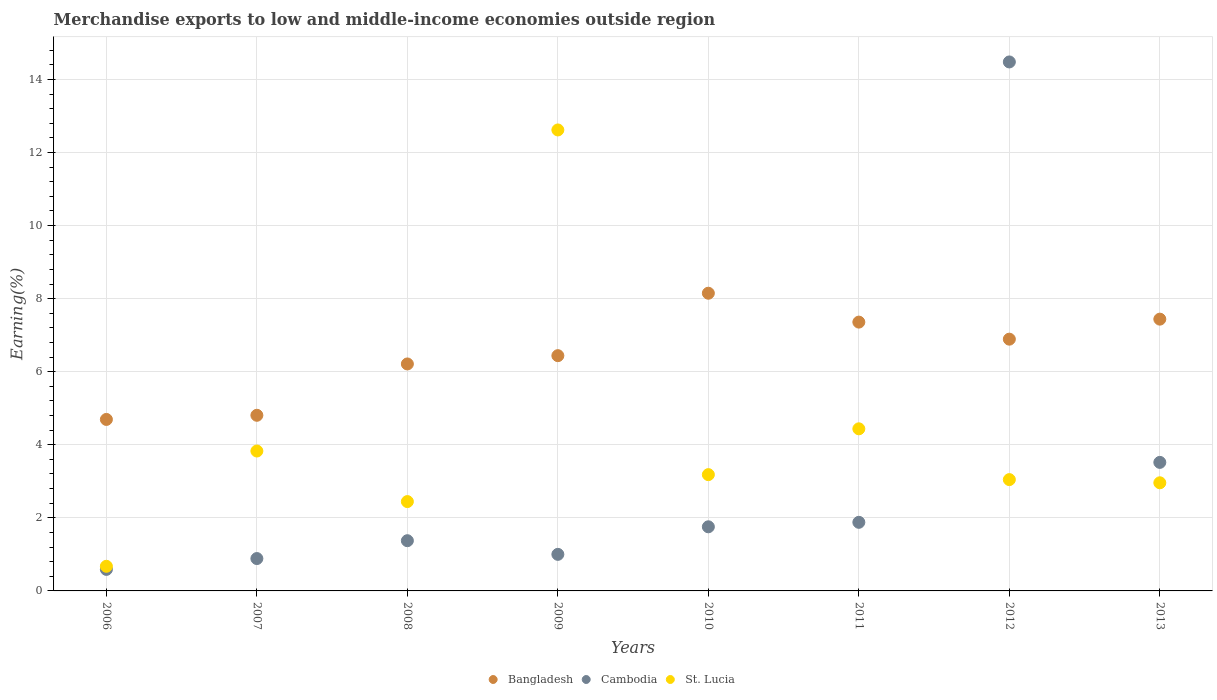What is the percentage of amount earned from merchandise exports in Cambodia in 2012?
Ensure brevity in your answer.  14.48. Across all years, what is the maximum percentage of amount earned from merchandise exports in St. Lucia?
Your answer should be very brief. 12.62. Across all years, what is the minimum percentage of amount earned from merchandise exports in Bangladesh?
Ensure brevity in your answer.  4.69. In which year was the percentage of amount earned from merchandise exports in St. Lucia maximum?
Provide a succinct answer. 2009. What is the total percentage of amount earned from merchandise exports in Cambodia in the graph?
Offer a terse response. 25.48. What is the difference between the percentage of amount earned from merchandise exports in Cambodia in 2007 and that in 2010?
Offer a terse response. -0.87. What is the difference between the percentage of amount earned from merchandise exports in Bangladesh in 2008 and the percentage of amount earned from merchandise exports in Cambodia in 2007?
Keep it short and to the point. 5.33. What is the average percentage of amount earned from merchandise exports in Bangladesh per year?
Offer a terse response. 6.5. In the year 2008, what is the difference between the percentage of amount earned from merchandise exports in Cambodia and percentage of amount earned from merchandise exports in St. Lucia?
Keep it short and to the point. -1.07. What is the ratio of the percentage of amount earned from merchandise exports in St. Lucia in 2007 to that in 2010?
Offer a very short reply. 1.2. Is the difference between the percentage of amount earned from merchandise exports in Cambodia in 2007 and 2011 greater than the difference between the percentage of amount earned from merchandise exports in St. Lucia in 2007 and 2011?
Make the answer very short. No. What is the difference between the highest and the second highest percentage of amount earned from merchandise exports in Bangladesh?
Offer a very short reply. 0.71. What is the difference between the highest and the lowest percentage of amount earned from merchandise exports in Bangladesh?
Offer a terse response. 3.45. Is the sum of the percentage of amount earned from merchandise exports in Bangladesh in 2008 and 2010 greater than the maximum percentage of amount earned from merchandise exports in St. Lucia across all years?
Offer a very short reply. Yes. Is it the case that in every year, the sum of the percentage of amount earned from merchandise exports in St. Lucia and percentage of amount earned from merchandise exports in Cambodia  is greater than the percentage of amount earned from merchandise exports in Bangladesh?
Your answer should be compact. No. Does the percentage of amount earned from merchandise exports in Cambodia monotonically increase over the years?
Your answer should be compact. No. How many years are there in the graph?
Your response must be concise. 8. What is the difference between two consecutive major ticks on the Y-axis?
Your response must be concise. 2. Does the graph contain any zero values?
Provide a short and direct response. No. Where does the legend appear in the graph?
Keep it short and to the point. Bottom center. How many legend labels are there?
Provide a succinct answer. 3. What is the title of the graph?
Your response must be concise. Merchandise exports to low and middle-income economies outside region. What is the label or title of the X-axis?
Your response must be concise. Years. What is the label or title of the Y-axis?
Your answer should be compact. Earning(%). What is the Earning(%) of Bangladesh in 2006?
Keep it short and to the point. 4.69. What is the Earning(%) in Cambodia in 2006?
Ensure brevity in your answer.  0.59. What is the Earning(%) of St. Lucia in 2006?
Give a very brief answer. 0.67. What is the Earning(%) in Bangladesh in 2007?
Keep it short and to the point. 4.81. What is the Earning(%) in Cambodia in 2007?
Give a very brief answer. 0.89. What is the Earning(%) of St. Lucia in 2007?
Offer a terse response. 3.83. What is the Earning(%) in Bangladesh in 2008?
Keep it short and to the point. 6.21. What is the Earning(%) in Cambodia in 2008?
Keep it short and to the point. 1.37. What is the Earning(%) of St. Lucia in 2008?
Provide a succinct answer. 2.45. What is the Earning(%) in Bangladesh in 2009?
Ensure brevity in your answer.  6.44. What is the Earning(%) of Cambodia in 2009?
Make the answer very short. 1. What is the Earning(%) in St. Lucia in 2009?
Give a very brief answer. 12.62. What is the Earning(%) of Bangladesh in 2010?
Your response must be concise. 8.15. What is the Earning(%) of Cambodia in 2010?
Offer a very short reply. 1.75. What is the Earning(%) in St. Lucia in 2010?
Keep it short and to the point. 3.18. What is the Earning(%) of Bangladesh in 2011?
Your answer should be compact. 7.36. What is the Earning(%) in Cambodia in 2011?
Keep it short and to the point. 1.88. What is the Earning(%) in St. Lucia in 2011?
Your response must be concise. 4.44. What is the Earning(%) of Bangladesh in 2012?
Your response must be concise. 6.89. What is the Earning(%) in Cambodia in 2012?
Give a very brief answer. 14.48. What is the Earning(%) in St. Lucia in 2012?
Your answer should be compact. 3.05. What is the Earning(%) in Bangladesh in 2013?
Provide a short and direct response. 7.44. What is the Earning(%) in Cambodia in 2013?
Your answer should be compact. 3.52. What is the Earning(%) of St. Lucia in 2013?
Provide a succinct answer. 2.96. Across all years, what is the maximum Earning(%) of Bangladesh?
Provide a succinct answer. 8.15. Across all years, what is the maximum Earning(%) of Cambodia?
Keep it short and to the point. 14.48. Across all years, what is the maximum Earning(%) of St. Lucia?
Your answer should be very brief. 12.62. Across all years, what is the minimum Earning(%) of Bangladesh?
Make the answer very short. 4.69. Across all years, what is the minimum Earning(%) in Cambodia?
Your answer should be compact. 0.59. Across all years, what is the minimum Earning(%) of St. Lucia?
Your answer should be very brief. 0.67. What is the total Earning(%) of Bangladesh in the graph?
Your answer should be very brief. 51.98. What is the total Earning(%) of Cambodia in the graph?
Your answer should be compact. 25.48. What is the total Earning(%) of St. Lucia in the graph?
Provide a short and direct response. 33.19. What is the difference between the Earning(%) of Bangladesh in 2006 and that in 2007?
Offer a very short reply. -0.11. What is the difference between the Earning(%) in Cambodia in 2006 and that in 2007?
Your answer should be very brief. -0.3. What is the difference between the Earning(%) in St. Lucia in 2006 and that in 2007?
Your answer should be very brief. -3.15. What is the difference between the Earning(%) of Bangladesh in 2006 and that in 2008?
Your answer should be compact. -1.52. What is the difference between the Earning(%) in Cambodia in 2006 and that in 2008?
Provide a succinct answer. -0.79. What is the difference between the Earning(%) in St. Lucia in 2006 and that in 2008?
Your answer should be very brief. -1.77. What is the difference between the Earning(%) of Bangladesh in 2006 and that in 2009?
Your answer should be compact. -1.75. What is the difference between the Earning(%) in Cambodia in 2006 and that in 2009?
Offer a very short reply. -0.41. What is the difference between the Earning(%) of St. Lucia in 2006 and that in 2009?
Offer a terse response. -11.94. What is the difference between the Earning(%) in Bangladesh in 2006 and that in 2010?
Ensure brevity in your answer.  -3.45. What is the difference between the Earning(%) of Cambodia in 2006 and that in 2010?
Offer a very short reply. -1.17. What is the difference between the Earning(%) of St. Lucia in 2006 and that in 2010?
Provide a short and direct response. -2.51. What is the difference between the Earning(%) of Bangladesh in 2006 and that in 2011?
Provide a short and direct response. -2.66. What is the difference between the Earning(%) in Cambodia in 2006 and that in 2011?
Provide a succinct answer. -1.29. What is the difference between the Earning(%) in St. Lucia in 2006 and that in 2011?
Your response must be concise. -3.76. What is the difference between the Earning(%) in Bangladesh in 2006 and that in 2012?
Your response must be concise. -2.2. What is the difference between the Earning(%) in Cambodia in 2006 and that in 2012?
Make the answer very short. -13.89. What is the difference between the Earning(%) of St. Lucia in 2006 and that in 2012?
Ensure brevity in your answer.  -2.37. What is the difference between the Earning(%) of Bangladesh in 2006 and that in 2013?
Keep it short and to the point. -2.74. What is the difference between the Earning(%) of Cambodia in 2006 and that in 2013?
Ensure brevity in your answer.  -2.93. What is the difference between the Earning(%) of St. Lucia in 2006 and that in 2013?
Give a very brief answer. -2.29. What is the difference between the Earning(%) in Bangladesh in 2007 and that in 2008?
Offer a terse response. -1.41. What is the difference between the Earning(%) of Cambodia in 2007 and that in 2008?
Offer a terse response. -0.49. What is the difference between the Earning(%) of St. Lucia in 2007 and that in 2008?
Provide a short and direct response. 1.38. What is the difference between the Earning(%) of Bangladesh in 2007 and that in 2009?
Provide a short and direct response. -1.63. What is the difference between the Earning(%) in Cambodia in 2007 and that in 2009?
Ensure brevity in your answer.  -0.11. What is the difference between the Earning(%) of St. Lucia in 2007 and that in 2009?
Your response must be concise. -8.79. What is the difference between the Earning(%) in Bangladesh in 2007 and that in 2010?
Provide a succinct answer. -3.34. What is the difference between the Earning(%) in Cambodia in 2007 and that in 2010?
Your response must be concise. -0.87. What is the difference between the Earning(%) in St. Lucia in 2007 and that in 2010?
Give a very brief answer. 0.65. What is the difference between the Earning(%) in Bangladesh in 2007 and that in 2011?
Provide a succinct answer. -2.55. What is the difference between the Earning(%) in Cambodia in 2007 and that in 2011?
Ensure brevity in your answer.  -0.99. What is the difference between the Earning(%) of St. Lucia in 2007 and that in 2011?
Give a very brief answer. -0.61. What is the difference between the Earning(%) of Bangladesh in 2007 and that in 2012?
Provide a succinct answer. -2.08. What is the difference between the Earning(%) of Cambodia in 2007 and that in 2012?
Your answer should be compact. -13.59. What is the difference between the Earning(%) in St. Lucia in 2007 and that in 2012?
Provide a short and direct response. 0.78. What is the difference between the Earning(%) of Bangladesh in 2007 and that in 2013?
Ensure brevity in your answer.  -2.63. What is the difference between the Earning(%) of Cambodia in 2007 and that in 2013?
Keep it short and to the point. -2.63. What is the difference between the Earning(%) of St. Lucia in 2007 and that in 2013?
Ensure brevity in your answer.  0.87. What is the difference between the Earning(%) in Bangladesh in 2008 and that in 2009?
Offer a terse response. -0.23. What is the difference between the Earning(%) in Cambodia in 2008 and that in 2009?
Ensure brevity in your answer.  0.37. What is the difference between the Earning(%) of St. Lucia in 2008 and that in 2009?
Offer a very short reply. -10.17. What is the difference between the Earning(%) of Bangladesh in 2008 and that in 2010?
Keep it short and to the point. -1.94. What is the difference between the Earning(%) in Cambodia in 2008 and that in 2010?
Your response must be concise. -0.38. What is the difference between the Earning(%) in St. Lucia in 2008 and that in 2010?
Offer a terse response. -0.74. What is the difference between the Earning(%) of Bangladesh in 2008 and that in 2011?
Offer a terse response. -1.15. What is the difference between the Earning(%) in Cambodia in 2008 and that in 2011?
Ensure brevity in your answer.  -0.5. What is the difference between the Earning(%) of St. Lucia in 2008 and that in 2011?
Ensure brevity in your answer.  -1.99. What is the difference between the Earning(%) in Bangladesh in 2008 and that in 2012?
Offer a terse response. -0.68. What is the difference between the Earning(%) of Cambodia in 2008 and that in 2012?
Provide a short and direct response. -13.1. What is the difference between the Earning(%) of St. Lucia in 2008 and that in 2012?
Provide a short and direct response. -0.6. What is the difference between the Earning(%) in Bangladesh in 2008 and that in 2013?
Make the answer very short. -1.23. What is the difference between the Earning(%) of Cambodia in 2008 and that in 2013?
Give a very brief answer. -2.14. What is the difference between the Earning(%) of St. Lucia in 2008 and that in 2013?
Give a very brief answer. -0.51. What is the difference between the Earning(%) in Bangladesh in 2009 and that in 2010?
Your answer should be very brief. -1.71. What is the difference between the Earning(%) of Cambodia in 2009 and that in 2010?
Give a very brief answer. -0.75. What is the difference between the Earning(%) in St. Lucia in 2009 and that in 2010?
Your answer should be very brief. 9.43. What is the difference between the Earning(%) in Bangladesh in 2009 and that in 2011?
Your answer should be very brief. -0.92. What is the difference between the Earning(%) in Cambodia in 2009 and that in 2011?
Your response must be concise. -0.88. What is the difference between the Earning(%) of St. Lucia in 2009 and that in 2011?
Your response must be concise. 8.18. What is the difference between the Earning(%) of Bangladesh in 2009 and that in 2012?
Keep it short and to the point. -0.45. What is the difference between the Earning(%) of Cambodia in 2009 and that in 2012?
Your response must be concise. -13.48. What is the difference between the Earning(%) in St. Lucia in 2009 and that in 2012?
Ensure brevity in your answer.  9.57. What is the difference between the Earning(%) in Bangladesh in 2009 and that in 2013?
Provide a short and direct response. -1. What is the difference between the Earning(%) of Cambodia in 2009 and that in 2013?
Offer a very short reply. -2.52. What is the difference between the Earning(%) of St. Lucia in 2009 and that in 2013?
Offer a terse response. 9.66. What is the difference between the Earning(%) in Bangladesh in 2010 and that in 2011?
Offer a very short reply. 0.79. What is the difference between the Earning(%) in Cambodia in 2010 and that in 2011?
Give a very brief answer. -0.12. What is the difference between the Earning(%) of St. Lucia in 2010 and that in 2011?
Offer a terse response. -1.25. What is the difference between the Earning(%) of Bangladesh in 2010 and that in 2012?
Make the answer very short. 1.26. What is the difference between the Earning(%) of Cambodia in 2010 and that in 2012?
Your answer should be compact. -12.72. What is the difference between the Earning(%) of St. Lucia in 2010 and that in 2012?
Offer a very short reply. 0.14. What is the difference between the Earning(%) in Bangladesh in 2010 and that in 2013?
Provide a short and direct response. 0.71. What is the difference between the Earning(%) of Cambodia in 2010 and that in 2013?
Offer a very short reply. -1.76. What is the difference between the Earning(%) of St. Lucia in 2010 and that in 2013?
Provide a succinct answer. 0.22. What is the difference between the Earning(%) in Bangladesh in 2011 and that in 2012?
Your response must be concise. 0.47. What is the difference between the Earning(%) of Cambodia in 2011 and that in 2012?
Keep it short and to the point. -12.6. What is the difference between the Earning(%) of St. Lucia in 2011 and that in 2012?
Give a very brief answer. 1.39. What is the difference between the Earning(%) of Bangladesh in 2011 and that in 2013?
Provide a succinct answer. -0.08. What is the difference between the Earning(%) of Cambodia in 2011 and that in 2013?
Provide a short and direct response. -1.64. What is the difference between the Earning(%) of St. Lucia in 2011 and that in 2013?
Give a very brief answer. 1.48. What is the difference between the Earning(%) in Bangladesh in 2012 and that in 2013?
Give a very brief answer. -0.55. What is the difference between the Earning(%) of Cambodia in 2012 and that in 2013?
Your response must be concise. 10.96. What is the difference between the Earning(%) in St. Lucia in 2012 and that in 2013?
Your answer should be compact. 0.09. What is the difference between the Earning(%) of Bangladesh in 2006 and the Earning(%) of Cambodia in 2007?
Keep it short and to the point. 3.81. What is the difference between the Earning(%) in Bangladesh in 2006 and the Earning(%) in St. Lucia in 2007?
Ensure brevity in your answer.  0.86. What is the difference between the Earning(%) of Cambodia in 2006 and the Earning(%) of St. Lucia in 2007?
Your answer should be very brief. -3.24. What is the difference between the Earning(%) in Bangladesh in 2006 and the Earning(%) in Cambodia in 2008?
Make the answer very short. 3.32. What is the difference between the Earning(%) in Bangladesh in 2006 and the Earning(%) in St. Lucia in 2008?
Offer a very short reply. 2.25. What is the difference between the Earning(%) of Cambodia in 2006 and the Earning(%) of St. Lucia in 2008?
Ensure brevity in your answer.  -1.86. What is the difference between the Earning(%) in Bangladesh in 2006 and the Earning(%) in Cambodia in 2009?
Your answer should be compact. 3.69. What is the difference between the Earning(%) in Bangladesh in 2006 and the Earning(%) in St. Lucia in 2009?
Provide a short and direct response. -7.92. What is the difference between the Earning(%) in Cambodia in 2006 and the Earning(%) in St. Lucia in 2009?
Your response must be concise. -12.03. What is the difference between the Earning(%) of Bangladesh in 2006 and the Earning(%) of Cambodia in 2010?
Ensure brevity in your answer.  2.94. What is the difference between the Earning(%) of Bangladesh in 2006 and the Earning(%) of St. Lucia in 2010?
Provide a short and direct response. 1.51. What is the difference between the Earning(%) of Cambodia in 2006 and the Earning(%) of St. Lucia in 2010?
Your response must be concise. -2.59. What is the difference between the Earning(%) in Bangladesh in 2006 and the Earning(%) in Cambodia in 2011?
Ensure brevity in your answer.  2.82. What is the difference between the Earning(%) of Bangladesh in 2006 and the Earning(%) of St. Lucia in 2011?
Your response must be concise. 0.26. What is the difference between the Earning(%) in Cambodia in 2006 and the Earning(%) in St. Lucia in 2011?
Give a very brief answer. -3.85. What is the difference between the Earning(%) in Bangladesh in 2006 and the Earning(%) in Cambodia in 2012?
Keep it short and to the point. -9.78. What is the difference between the Earning(%) of Bangladesh in 2006 and the Earning(%) of St. Lucia in 2012?
Ensure brevity in your answer.  1.65. What is the difference between the Earning(%) in Cambodia in 2006 and the Earning(%) in St. Lucia in 2012?
Make the answer very short. -2.46. What is the difference between the Earning(%) of Bangladesh in 2006 and the Earning(%) of Cambodia in 2013?
Your response must be concise. 1.18. What is the difference between the Earning(%) of Bangladesh in 2006 and the Earning(%) of St. Lucia in 2013?
Your answer should be compact. 1.73. What is the difference between the Earning(%) in Cambodia in 2006 and the Earning(%) in St. Lucia in 2013?
Your answer should be very brief. -2.37. What is the difference between the Earning(%) of Bangladesh in 2007 and the Earning(%) of Cambodia in 2008?
Offer a very short reply. 3.43. What is the difference between the Earning(%) of Bangladesh in 2007 and the Earning(%) of St. Lucia in 2008?
Your answer should be very brief. 2.36. What is the difference between the Earning(%) in Cambodia in 2007 and the Earning(%) in St. Lucia in 2008?
Offer a terse response. -1.56. What is the difference between the Earning(%) in Bangladesh in 2007 and the Earning(%) in Cambodia in 2009?
Provide a short and direct response. 3.81. What is the difference between the Earning(%) in Bangladesh in 2007 and the Earning(%) in St. Lucia in 2009?
Your answer should be compact. -7.81. What is the difference between the Earning(%) in Cambodia in 2007 and the Earning(%) in St. Lucia in 2009?
Your response must be concise. -11.73. What is the difference between the Earning(%) in Bangladesh in 2007 and the Earning(%) in Cambodia in 2010?
Provide a succinct answer. 3.05. What is the difference between the Earning(%) of Bangladesh in 2007 and the Earning(%) of St. Lucia in 2010?
Provide a short and direct response. 1.62. What is the difference between the Earning(%) of Cambodia in 2007 and the Earning(%) of St. Lucia in 2010?
Your answer should be very brief. -2.3. What is the difference between the Earning(%) of Bangladesh in 2007 and the Earning(%) of Cambodia in 2011?
Your response must be concise. 2.93. What is the difference between the Earning(%) in Bangladesh in 2007 and the Earning(%) in St. Lucia in 2011?
Ensure brevity in your answer.  0.37. What is the difference between the Earning(%) of Cambodia in 2007 and the Earning(%) of St. Lucia in 2011?
Your response must be concise. -3.55. What is the difference between the Earning(%) in Bangladesh in 2007 and the Earning(%) in Cambodia in 2012?
Give a very brief answer. -9.67. What is the difference between the Earning(%) in Bangladesh in 2007 and the Earning(%) in St. Lucia in 2012?
Your response must be concise. 1.76. What is the difference between the Earning(%) of Cambodia in 2007 and the Earning(%) of St. Lucia in 2012?
Your answer should be very brief. -2.16. What is the difference between the Earning(%) of Bangladesh in 2007 and the Earning(%) of Cambodia in 2013?
Your answer should be very brief. 1.29. What is the difference between the Earning(%) of Bangladesh in 2007 and the Earning(%) of St. Lucia in 2013?
Make the answer very short. 1.85. What is the difference between the Earning(%) in Cambodia in 2007 and the Earning(%) in St. Lucia in 2013?
Give a very brief answer. -2.07. What is the difference between the Earning(%) of Bangladesh in 2008 and the Earning(%) of Cambodia in 2009?
Keep it short and to the point. 5.21. What is the difference between the Earning(%) of Bangladesh in 2008 and the Earning(%) of St. Lucia in 2009?
Your response must be concise. -6.4. What is the difference between the Earning(%) of Cambodia in 2008 and the Earning(%) of St. Lucia in 2009?
Provide a succinct answer. -11.24. What is the difference between the Earning(%) in Bangladesh in 2008 and the Earning(%) in Cambodia in 2010?
Keep it short and to the point. 4.46. What is the difference between the Earning(%) of Bangladesh in 2008 and the Earning(%) of St. Lucia in 2010?
Your answer should be compact. 3.03. What is the difference between the Earning(%) in Cambodia in 2008 and the Earning(%) in St. Lucia in 2010?
Keep it short and to the point. -1.81. What is the difference between the Earning(%) of Bangladesh in 2008 and the Earning(%) of Cambodia in 2011?
Provide a short and direct response. 4.33. What is the difference between the Earning(%) in Bangladesh in 2008 and the Earning(%) in St. Lucia in 2011?
Ensure brevity in your answer.  1.78. What is the difference between the Earning(%) in Cambodia in 2008 and the Earning(%) in St. Lucia in 2011?
Provide a short and direct response. -3.06. What is the difference between the Earning(%) in Bangladesh in 2008 and the Earning(%) in Cambodia in 2012?
Provide a succinct answer. -8.27. What is the difference between the Earning(%) in Bangladesh in 2008 and the Earning(%) in St. Lucia in 2012?
Provide a succinct answer. 3.17. What is the difference between the Earning(%) of Cambodia in 2008 and the Earning(%) of St. Lucia in 2012?
Offer a terse response. -1.67. What is the difference between the Earning(%) in Bangladesh in 2008 and the Earning(%) in Cambodia in 2013?
Provide a succinct answer. 2.69. What is the difference between the Earning(%) in Bangladesh in 2008 and the Earning(%) in St. Lucia in 2013?
Provide a succinct answer. 3.25. What is the difference between the Earning(%) in Cambodia in 2008 and the Earning(%) in St. Lucia in 2013?
Offer a very short reply. -1.58. What is the difference between the Earning(%) in Bangladesh in 2009 and the Earning(%) in Cambodia in 2010?
Ensure brevity in your answer.  4.68. What is the difference between the Earning(%) in Bangladesh in 2009 and the Earning(%) in St. Lucia in 2010?
Provide a succinct answer. 3.26. What is the difference between the Earning(%) in Cambodia in 2009 and the Earning(%) in St. Lucia in 2010?
Provide a short and direct response. -2.18. What is the difference between the Earning(%) of Bangladesh in 2009 and the Earning(%) of Cambodia in 2011?
Keep it short and to the point. 4.56. What is the difference between the Earning(%) of Bangladesh in 2009 and the Earning(%) of St. Lucia in 2011?
Your answer should be compact. 2. What is the difference between the Earning(%) of Cambodia in 2009 and the Earning(%) of St. Lucia in 2011?
Offer a very short reply. -3.44. What is the difference between the Earning(%) of Bangladesh in 2009 and the Earning(%) of Cambodia in 2012?
Ensure brevity in your answer.  -8.04. What is the difference between the Earning(%) in Bangladesh in 2009 and the Earning(%) in St. Lucia in 2012?
Offer a terse response. 3.39. What is the difference between the Earning(%) in Cambodia in 2009 and the Earning(%) in St. Lucia in 2012?
Provide a short and direct response. -2.05. What is the difference between the Earning(%) of Bangladesh in 2009 and the Earning(%) of Cambodia in 2013?
Make the answer very short. 2.92. What is the difference between the Earning(%) in Bangladesh in 2009 and the Earning(%) in St. Lucia in 2013?
Offer a very short reply. 3.48. What is the difference between the Earning(%) of Cambodia in 2009 and the Earning(%) of St. Lucia in 2013?
Ensure brevity in your answer.  -1.96. What is the difference between the Earning(%) of Bangladesh in 2010 and the Earning(%) of Cambodia in 2011?
Keep it short and to the point. 6.27. What is the difference between the Earning(%) of Bangladesh in 2010 and the Earning(%) of St. Lucia in 2011?
Ensure brevity in your answer.  3.71. What is the difference between the Earning(%) of Cambodia in 2010 and the Earning(%) of St. Lucia in 2011?
Your answer should be compact. -2.68. What is the difference between the Earning(%) in Bangladesh in 2010 and the Earning(%) in Cambodia in 2012?
Keep it short and to the point. -6.33. What is the difference between the Earning(%) in Bangladesh in 2010 and the Earning(%) in St. Lucia in 2012?
Provide a succinct answer. 5.1. What is the difference between the Earning(%) of Cambodia in 2010 and the Earning(%) of St. Lucia in 2012?
Give a very brief answer. -1.29. What is the difference between the Earning(%) in Bangladesh in 2010 and the Earning(%) in Cambodia in 2013?
Offer a very short reply. 4.63. What is the difference between the Earning(%) of Bangladesh in 2010 and the Earning(%) of St. Lucia in 2013?
Provide a short and direct response. 5.19. What is the difference between the Earning(%) of Cambodia in 2010 and the Earning(%) of St. Lucia in 2013?
Your answer should be compact. -1.2. What is the difference between the Earning(%) of Bangladesh in 2011 and the Earning(%) of Cambodia in 2012?
Offer a very short reply. -7.12. What is the difference between the Earning(%) in Bangladesh in 2011 and the Earning(%) in St. Lucia in 2012?
Keep it short and to the point. 4.31. What is the difference between the Earning(%) of Cambodia in 2011 and the Earning(%) of St. Lucia in 2012?
Provide a succinct answer. -1.17. What is the difference between the Earning(%) in Bangladesh in 2011 and the Earning(%) in Cambodia in 2013?
Your response must be concise. 3.84. What is the difference between the Earning(%) of Bangladesh in 2011 and the Earning(%) of St. Lucia in 2013?
Your answer should be very brief. 4.4. What is the difference between the Earning(%) of Cambodia in 2011 and the Earning(%) of St. Lucia in 2013?
Give a very brief answer. -1.08. What is the difference between the Earning(%) in Bangladesh in 2012 and the Earning(%) in Cambodia in 2013?
Your response must be concise. 3.37. What is the difference between the Earning(%) of Bangladesh in 2012 and the Earning(%) of St. Lucia in 2013?
Make the answer very short. 3.93. What is the difference between the Earning(%) in Cambodia in 2012 and the Earning(%) in St. Lucia in 2013?
Make the answer very short. 11.52. What is the average Earning(%) of Bangladesh per year?
Provide a short and direct response. 6.5. What is the average Earning(%) in Cambodia per year?
Offer a very short reply. 3.18. What is the average Earning(%) of St. Lucia per year?
Make the answer very short. 4.15. In the year 2006, what is the difference between the Earning(%) of Bangladesh and Earning(%) of Cambodia?
Provide a succinct answer. 4.1. In the year 2006, what is the difference between the Earning(%) of Bangladesh and Earning(%) of St. Lucia?
Offer a terse response. 4.02. In the year 2006, what is the difference between the Earning(%) in Cambodia and Earning(%) in St. Lucia?
Make the answer very short. -0.08. In the year 2007, what is the difference between the Earning(%) in Bangladesh and Earning(%) in Cambodia?
Your response must be concise. 3.92. In the year 2007, what is the difference between the Earning(%) in Bangladesh and Earning(%) in St. Lucia?
Make the answer very short. 0.98. In the year 2007, what is the difference between the Earning(%) of Cambodia and Earning(%) of St. Lucia?
Provide a succinct answer. -2.94. In the year 2008, what is the difference between the Earning(%) in Bangladesh and Earning(%) in Cambodia?
Your answer should be compact. 4.84. In the year 2008, what is the difference between the Earning(%) in Bangladesh and Earning(%) in St. Lucia?
Offer a terse response. 3.77. In the year 2008, what is the difference between the Earning(%) in Cambodia and Earning(%) in St. Lucia?
Your answer should be very brief. -1.07. In the year 2009, what is the difference between the Earning(%) in Bangladesh and Earning(%) in Cambodia?
Provide a succinct answer. 5.44. In the year 2009, what is the difference between the Earning(%) of Bangladesh and Earning(%) of St. Lucia?
Give a very brief answer. -6.18. In the year 2009, what is the difference between the Earning(%) in Cambodia and Earning(%) in St. Lucia?
Keep it short and to the point. -11.62. In the year 2010, what is the difference between the Earning(%) in Bangladesh and Earning(%) in Cambodia?
Provide a short and direct response. 6.39. In the year 2010, what is the difference between the Earning(%) of Bangladesh and Earning(%) of St. Lucia?
Ensure brevity in your answer.  4.97. In the year 2010, what is the difference between the Earning(%) of Cambodia and Earning(%) of St. Lucia?
Give a very brief answer. -1.43. In the year 2011, what is the difference between the Earning(%) of Bangladesh and Earning(%) of Cambodia?
Your answer should be compact. 5.48. In the year 2011, what is the difference between the Earning(%) in Bangladesh and Earning(%) in St. Lucia?
Offer a very short reply. 2.92. In the year 2011, what is the difference between the Earning(%) in Cambodia and Earning(%) in St. Lucia?
Keep it short and to the point. -2.56. In the year 2012, what is the difference between the Earning(%) of Bangladesh and Earning(%) of Cambodia?
Your answer should be very brief. -7.59. In the year 2012, what is the difference between the Earning(%) in Bangladesh and Earning(%) in St. Lucia?
Your response must be concise. 3.84. In the year 2012, what is the difference between the Earning(%) of Cambodia and Earning(%) of St. Lucia?
Your response must be concise. 11.43. In the year 2013, what is the difference between the Earning(%) in Bangladesh and Earning(%) in Cambodia?
Your response must be concise. 3.92. In the year 2013, what is the difference between the Earning(%) in Bangladesh and Earning(%) in St. Lucia?
Your answer should be compact. 4.48. In the year 2013, what is the difference between the Earning(%) in Cambodia and Earning(%) in St. Lucia?
Your answer should be compact. 0.56. What is the ratio of the Earning(%) in Bangladesh in 2006 to that in 2007?
Provide a short and direct response. 0.98. What is the ratio of the Earning(%) in Cambodia in 2006 to that in 2007?
Give a very brief answer. 0.67. What is the ratio of the Earning(%) of St. Lucia in 2006 to that in 2007?
Ensure brevity in your answer.  0.18. What is the ratio of the Earning(%) in Bangladesh in 2006 to that in 2008?
Keep it short and to the point. 0.76. What is the ratio of the Earning(%) in Cambodia in 2006 to that in 2008?
Your answer should be very brief. 0.43. What is the ratio of the Earning(%) of St. Lucia in 2006 to that in 2008?
Provide a succinct answer. 0.28. What is the ratio of the Earning(%) in Bangladesh in 2006 to that in 2009?
Make the answer very short. 0.73. What is the ratio of the Earning(%) in Cambodia in 2006 to that in 2009?
Provide a succinct answer. 0.59. What is the ratio of the Earning(%) in St. Lucia in 2006 to that in 2009?
Ensure brevity in your answer.  0.05. What is the ratio of the Earning(%) in Bangladesh in 2006 to that in 2010?
Provide a short and direct response. 0.58. What is the ratio of the Earning(%) of Cambodia in 2006 to that in 2010?
Offer a terse response. 0.34. What is the ratio of the Earning(%) of St. Lucia in 2006 to that in 2010?
Provide a short and direct response. 0.21. What is the ratio of the Earning(%) in Bangladesh in 2006 to that in 2011?
Provide a succinct answer. 0.64. What is the ratio of the Earning(%) in Cambodia in 2006 to that in 2011?
Your response must be concise. 0.31. What is the ratio of the Earning(%) in St. Lucia in 2006 to that in 2011?
Offer a very short reply. 0.15. What is the ratio of the Earning(%) in Bangladesh in 2006 to that in 2012?
Provide a short and direct response. 0.68. What is the ratio of the Earning(%) in Cambodia in 2006 to that in 2012?
Offer a very short reply. 0.04. What is the ratio of the Earning(%) of St. Lucia in 2006 to that in 2012?
Offer a very short reply. 0.22. What is the ratio of the Earning(%) of Bangladesh in 2006 to that in 2013?
Offer a terse response. 0.63. What is the ratio of the Earning(%) in Cambodia in 2006 to that in 2013?
Make the answer very short. 0.17. What is the ratio of the Earning(%) of St. Lucia in 2006 to that in 2013?
Keep it short and to the point. 0.23. What is the ratio of the Earning(%) of Bangladesh in 2007 to that in 2008?
Your answer should be compact. 0.77. What is the ratio of the Earning(%) of Cambodia in 2007 to that in 2008?
Offer a very short reply. 0.64. What is the ratio of the Earning(%) in St. Lucia in 2007 to that in 2008?
Ensure brevity in your answer.  1.57. What is the ratio of the Earning(%) of Bangladesh in 2007 to that in 2009?
Provide a short and direct response. 0.75. What is the ratio of the Earning(%) of Cambodia in 2007 to that in 2009?
Provide a succinct answer. 0.89. What is the ratio of the Earning(%) of St. Lucia in 2007 to that in 2009?
Give a very brief answer. 0.3. What is the ratio of the Earning(%) in Bangladesh in 2007 to that in 2010?
Provide a short and direct response. 0.59. What is the ratio of the Earning(%) in Cambodia in 2007 to that in 2010?
Your answer should be compact. 0.5. What is the ratio of the Earning(%) in St. Lucia in 2007 to that in 2010?
Provide a succinct answer. 1.2. What is the ratio of the Earning(%) of Bangladesh in 2007 to that in 2011?
Your response must be concise. 0.65. What is the ratio of the Earning(%) of Cambodia in 2007 to that in 2011?
Offer a very short reply. 0.47. What is the ratio of the Earning(%) in St. Lucia in 2007 to that in 2011?
Provide a succinct answer. 0.86. What is the ratio of the Earning(%) of Bangladesh in 2007 to that in 2012?
Ensure brevity in your answer.  0.7. What is the ratio of the Earning(%) in Cambodia in 2007 to that in 2012?
Your response must be concise. 0.06. What is the ratio of the Earning(%) in St. Lucia in 2007 to that in 2012?
Your answer should be compact. 1.26. What is the ratio of the Earning(%) of Bangladesh in 2007 to that in 2013?
Your response must be concise. 0.65. What is the ratio of the Earning(%) in Cambodia in 2007 to that in 2013?
Provide a short and direct response. 0.25. What is the ratio of the Earning(%) in St. Lucia in 2007 to that in 2013?
Give a very brief answer. 1.29. What is the ratio of the Earning(%) of Bangladesh in 2008 to that in 2009?
Ensure brevity in your answer.  0.96. What is the ratio of the Earning(%) in Cambodia in 2008 to that in 2009?
Your answer should be compact. 1.37. What is the ratio of the Earning(%) in St. Lucia in 2008 to that in 2009?
Offer a terse response. 0.19. What is the ratio of the Earning(%) of Bangladesh in 2008 to that in 2010?
Your response must be concise. 0.76. What is the ratio of the Earning(%) of Cambodia in 2008 to that in 2010?
Make the answer very short. 0.78. What is the ratio of the Earning(%) in St. Lucia in 2008 to that in 2010?
Your answer should be compact. 0.77. What is the ratio of the Earning(%) in Bangladesh in 2008 to that in 2011?
Offer a very short reply. 0.84. What is the ratio of the Earning(%) of Cambodia in 2008 to that in 2011?
Ensure brevity in your answer.  0.73. What is the ratio of the Earning(%) in St. Lucia in 2008 to that in 2011?
Your response must be concise. 0.55. What is the ratio of the Earning(%) in Bangladesh in 2008 to that in 2012?
Keep it short and to the point. 0.9. What is the ratio of the Earning(%) in Cambodia in 2008 to that in 2012?
Your response must be concise. 0.09. What is the ratio of the Earning(%) of St. Lucia in 2008 to that in 2012?
Keep it short and to the point. 0.8. What is the ratio of the Earning(%) of Bangladesh in 2008 to that in 2013?
Give a very brief answer. 0.84. What is the ratio of the Earning(%) of Cambodia in 2008 to that in 2013?
Your response must be concise. 0.39. What is the ratio of the Earning(%) in St. Lucia in 2008 to that in 2013?
Your answer should be very brief. 0.83. What is the ratio of the Earning(%) of Bangladesh in 2009 to that in 2010?
Provide a short and direct response. 0.79. What is the ratio of the Earning(%) in Cambodia in 2009 to that in 2010?
Your answer should be compact. 0.57. What is the ratio of the Earning(%) in St. Lucia in 2009 to that in 2010?
Offer a terse response. 3.96. What is the ratio of the Earning(%) of Bangladesh in 2009 to that in 2011?
Provide a succinct answer. 0.88. What is the ratio of the Earning(%) of Cambodia in 2009 to that in 2011?
Offer a very short reply. 0.53. What is the ratio of the Earning(%) of St. Lucia in 2009 to that in 2011?
Make the answer very short. 2.84. What is the ratio of the Earning(%) of Bangladesh in 2009 to that in 2012?
Provide a succinct answer. 0.93. What is the ratio of the Earning(%) in Cambodia in 2009 to that in 2012?
Your answer should be compact. 0.07. What is the ratio of the Earning(%) of St. Lucia in 2009 to that in 2012?
Keep it short and to the point. 4.14. What is the ratio of the Earning(%) of Bangladesh in 2009 to that in 2013?
Ensure brevity in your answer.  0.87. What is the ratio of the Earning(%) in Cambodia in 2009 to that in 2013?
Make the answer very short. 0.28. What is the ratio of the Earning(%) of St. Lucia in 2009 to that in 2013?
Make the answer very short. 4.26. What is the ratio of the Earning(%) of Bangladesh in 2010 to that in 2011?
Keep it short and to the point. 1.11. What is the ratio of the Earning(%) of Cambodia in 2010 to that in 2011?
Offer a very short reply. 0.93. What is the ratio of the Earning(%) of St. Lucia in 2010 to that in 2011?
Your answer should be compact. 0.72. What is the ratio of the Earning(%) in Bangladesh in 2010 to that in 2012?
Your response must be concise. 1.18. What is the ratio of the Earning(%) in Cambodia in 2010 to that in 2012?
Offer a terse response. 0.12. What is the ratio of the Earning(%) of St. Lucia in 2010 to that in 2012?
Offer a terse response. 1.04. What is the ratio of the Earning(%) of Bangladesh in 2010 to that in 2013?
Give a very brief answer. 1.1. What is the ratio of the Earning(%) in Cambodia in 2010 to that in 2013?
Keep it short and to the point. 0.5. What is the ratio of the Earning(%) in St. Lucia in 2010 to that in 2013?
Offer a terse response. 1.08. What is the ratio of the Earning(%) of Bangladesh in 2011 to that in 2012?
Make the answer very short. 1.07. What is the ratio of the Earning(%) of Cambodia in 2011 to that in 2012?
Provide a short and direct response. 0.13. What is the ratio of the Earning(%) of St. Lucia in 2011 to that in 2012?
Provide a succinct answer. 1.46. What is the ratio of the Earning(%) in Cambodia in 2011 to that in 2013?
Ensure brevity in your answer.  0.53. What is the ratio of the Earning(%) of St. Lucia in 2011 to that in 2013?
Your response must be concise. 1.5. What is the ratio of the Earning(%) of Bangladesh in 2012 to that in 2013?
Your response must be concise. 0.93. What is the ratio of the Earning(%) in Cambodia in 2012 to that in 2013?
Your answer should be very brief. 4.12. What is the ratio of the Earning(%) of St. Lucia in 2012 to that in 2013?
Keep it short and to the point. 1.03. What is the difference between the highest and the second highest Earning(%) in Bangladesh?
Your answer should be compact. 0.71. What is the difference between the highest and the second highest Earning(%) in Cambodia?
Offer a very short reply. 10.96. What is the difference between the highest and the second highest Earning(%) of St. Lucia?
Your answer should be compact. 8.18. What is the difference between the highest and the lowest Earning(%) in Bangladesh?
Offer a terse response. 3.45. What is the difference between the highest and the lowest Earning(%) in Cambodia?
Offer a terse response. 13.89. What is the difference between the highest and the lowest Earning(%) of St. Lucia?
Keep it short and to the point. 11.94. 